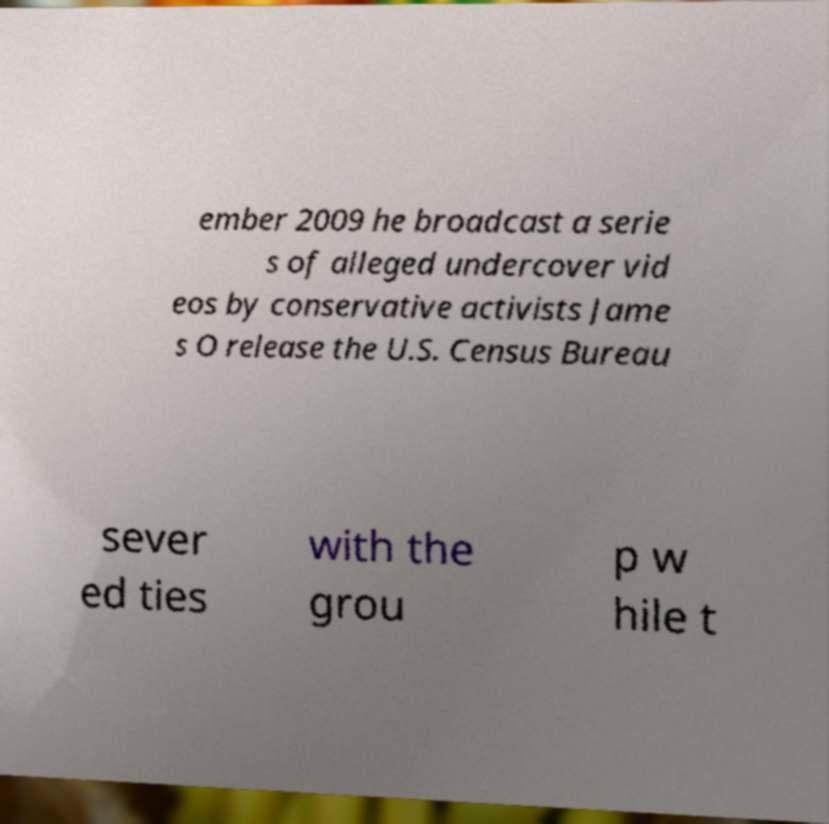Can you accurately transcribe the text from the provided image for me? ember 2009 he broadcast a serie s of alleged undercover vid eos by conservative activists Jame s O release the U.S. Census Bureau sever ed ties with the grou p w hile t 